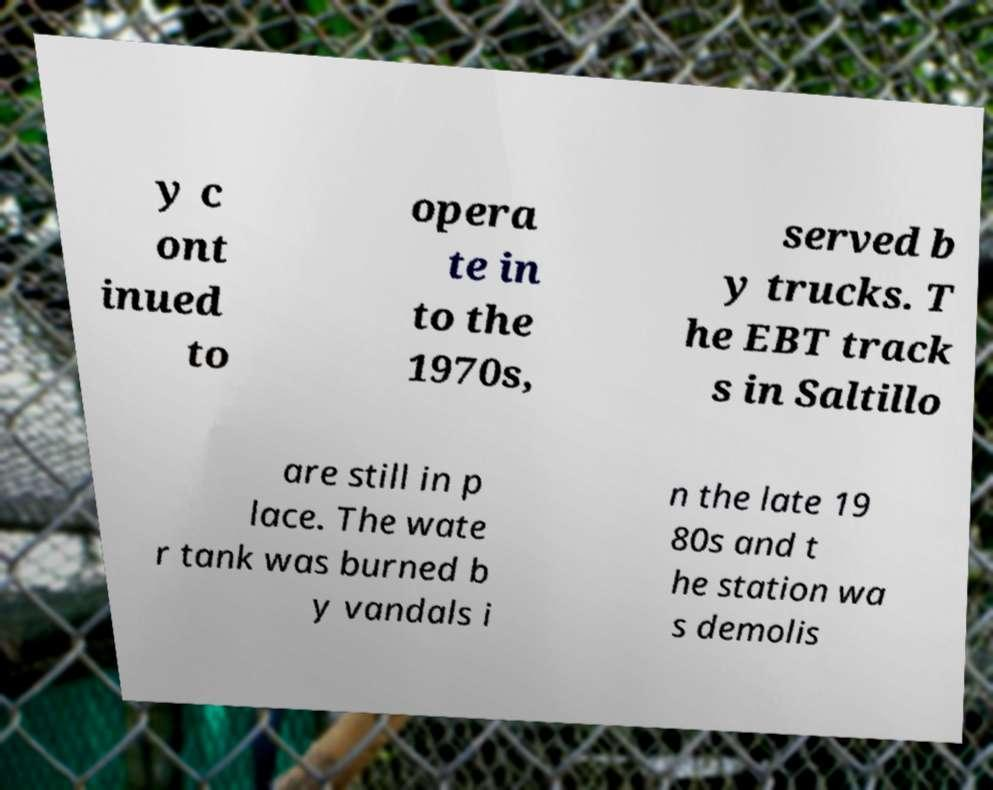For documentation purposes, I need the text within this image transcribed. Could you provide that? y c ont inued to opera te in to the 1970s, served b y trucks. T he EBT track s in Saltillo are still in p lace. The wate r tank was burned b y vandals i n the late 19 80s and t he station wa s demolis 